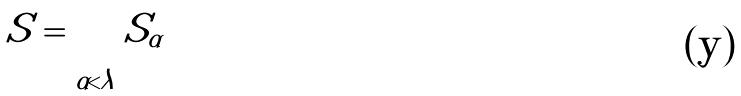<formula> <loc_0><loc_0><loc_500><loc_500>S = \bigcup _ { \alpha < \lambda } S _ { \alpha }</formula> 